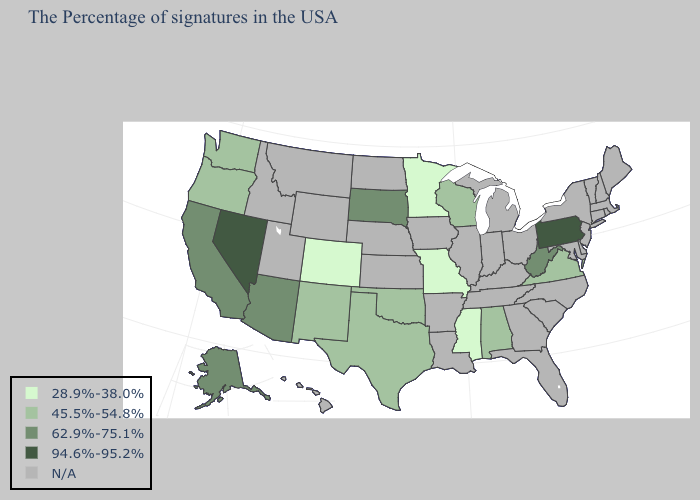Name the states that have a value in the range N/A?
Answer briefly. Maine, Massachusetts, Rhode Island, New Hampshire, Vermont, Connecticut, New York, New Jersey, Delaware, Maryland, North Carolina, South Carolina, Ohio, Florida, Georgia, Michigan, Kentucky, Indiana, Tennessee, Illinois, Louisiana, Arkansas, Iowa, Kansas, Nebraska, North Dakota, Wyoming, Utah, Montana, Idaho, Hawaii. What is the value of Massachusetts?
Quick response, please. N/A. Among the states that border West Virginia , does Virginia have the highest value?
Keep it brief. No. Does Nevada have the highest value in the USA?
Answer briefly. Yes. Does the first symbol in the legend represent the smallest category?
Concise answer only. Yes. What is the value of West Virginia?
Concise answer only. 62.9%-75.1%. Which states hav the highest value in the MidWest?
Short answer required. South Dakota. What is the value of Maryland?
Short answer required. N/A. Name the states that have a value in the range 28.9%-38.0%?
Be succinct. Mississippi, Missouri, Minnesota, Colorado. Name the states that have a value in the range N/A?
Write a very short answer. Maine, Massachusetts, Rhode Island, New Hampshire, Vermont, Connecticut, New York, New Jersey, Delaware, Maryland, North Carolina, South Carolina, Ohio, Florida, Georgia, Michigan, Kentucky, Indiana, Tennessee, Illinois, Louisiana, Arkansas, Iowa, Kansas, Nebraska, North Dakota, Wyoming, Utah, Montana, Idaho, Hawaii. Does South Dakota have the highest value in the MidWest?
Answer briefly. Yes. Does Oregon have the lowest value in the USA?
Keep it brief. No. Does Nevada have the highest value in the USA?
Be succinct. Yes. 